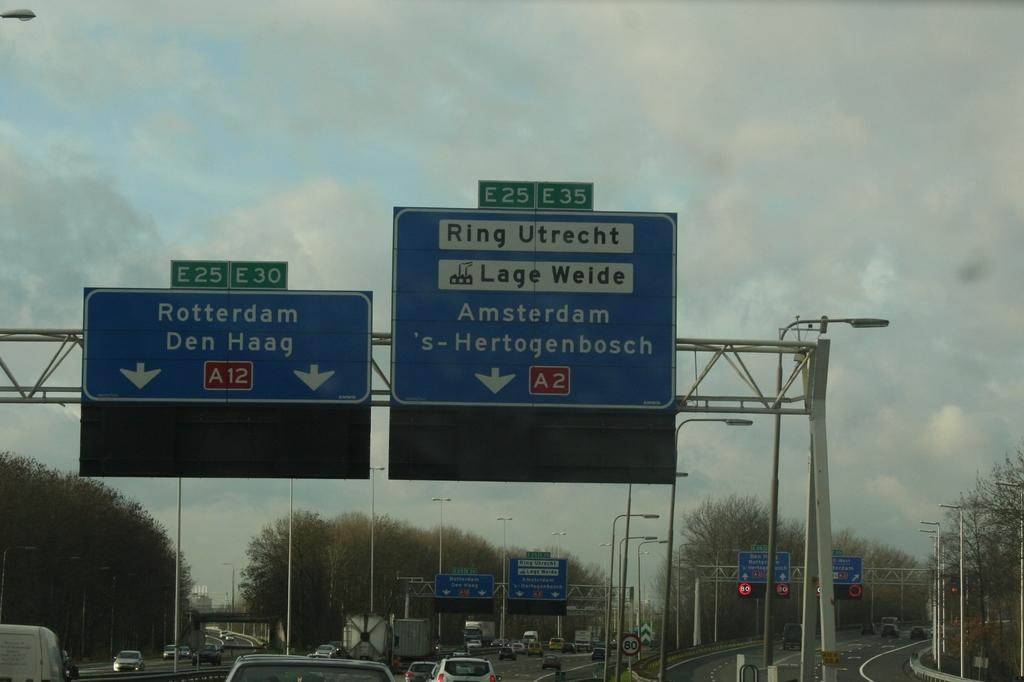Provide a one-sentence caption for the provided image. A traffic sign for Rotterdam next to one for Amsterdam. 